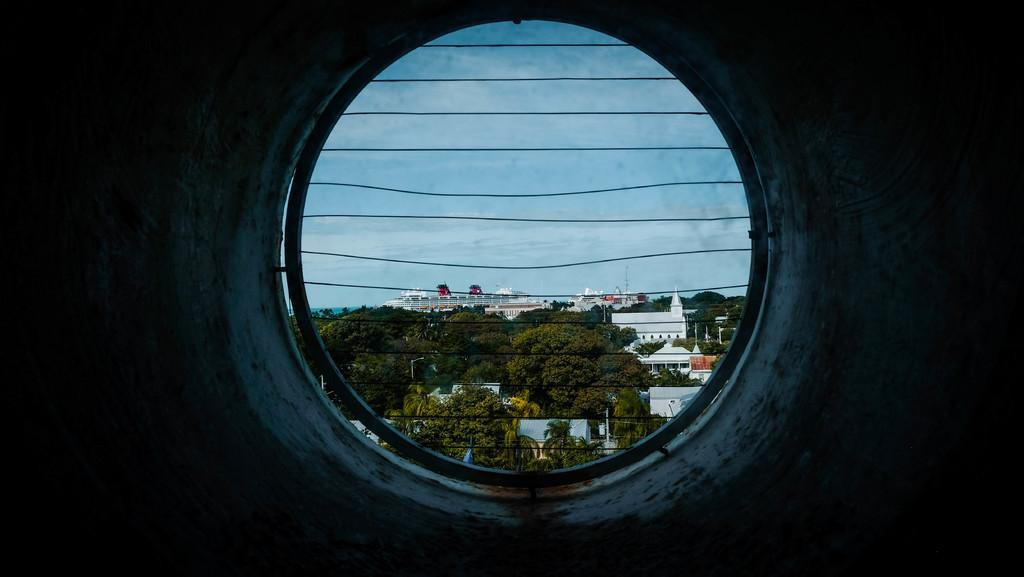What is the main feature of the image? There is a hole in a wall in the image. What can be seen in the background of the image? There are trees and buildings visible in the image. What other objects can be seen in the image? There are poles in the image. How would you describe the sky in the image? The sky is visible in the image and appears cloudy. How many seeds can be seen growing on the trees in the image? There are no seeds visible on the trees in the image; only the trees themselves are present. What type of soap is being used to clean the poles in the image? There is no soap or cleaning activity depicted in the image; the poles are simply standing in the scene. 